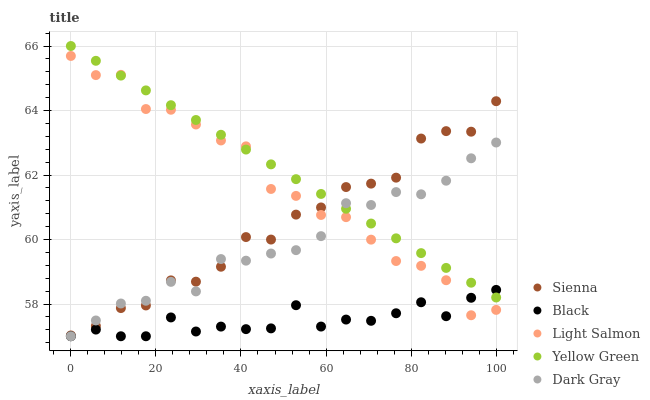Does Black have the minimum area under the curve?
Answer yes or no. Yes. Does Yellow Green have the maximum area under the curve?
Answer yes or no. Yes. Does Dark Gray have the minimum area under the curve?
Answer yes or no. No. Does Dark Gray have the maximum area under the curve?
Answer yes or no. No. Is Yellow Green the smoothest?
Answer yes or no. Yes. Is Light Salmon the roughest?
Answer yes or no. Yes. Is Dark Gray the smoothest?
Answer yes or no. No. Is Dark Gray the roughest?
Answer yes or no. No. Does Dark Gray have the lowest value?
Answer yes or no. Yes. Does Light Salmon have the lowest value?
Answer yes or no. No. Does Yellow Green have the highest value?
Answer yes or no. Yes. Does Dark Gray have the highest value?
Answer yes or no. No. Is Black less than Sienna?
Answer yes or no. Yes. Is Sienna greater than Black?
Answer yes or no. Yes. Does Sienna intersect Light Salmon?
Answer yes or no. Yes. Is Sienna less than Light Salmon?
Answer yes or no. No. Is Sienna greater than Light Salmon?
Answer yes or no. No. Does Black intersect Sienna?
Answer yes or no. No. 